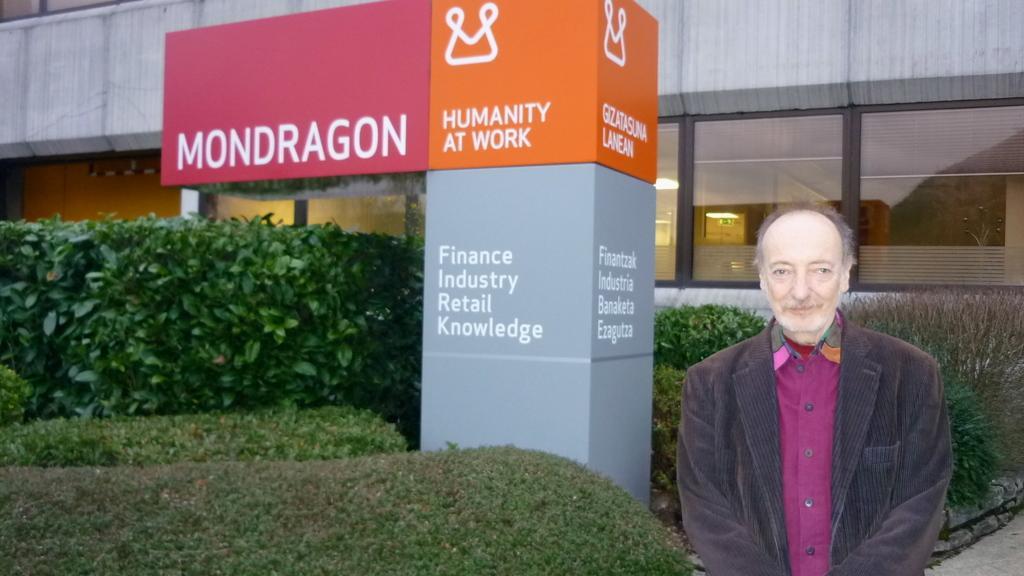Please provide a concise description of this image. In this image in front there is a person wearing a smile on his face. At the bottom there is grass on the surface. We can see plants and display boards in the center of the image. On the backside there is a building and we can see there are lights inside the building. 